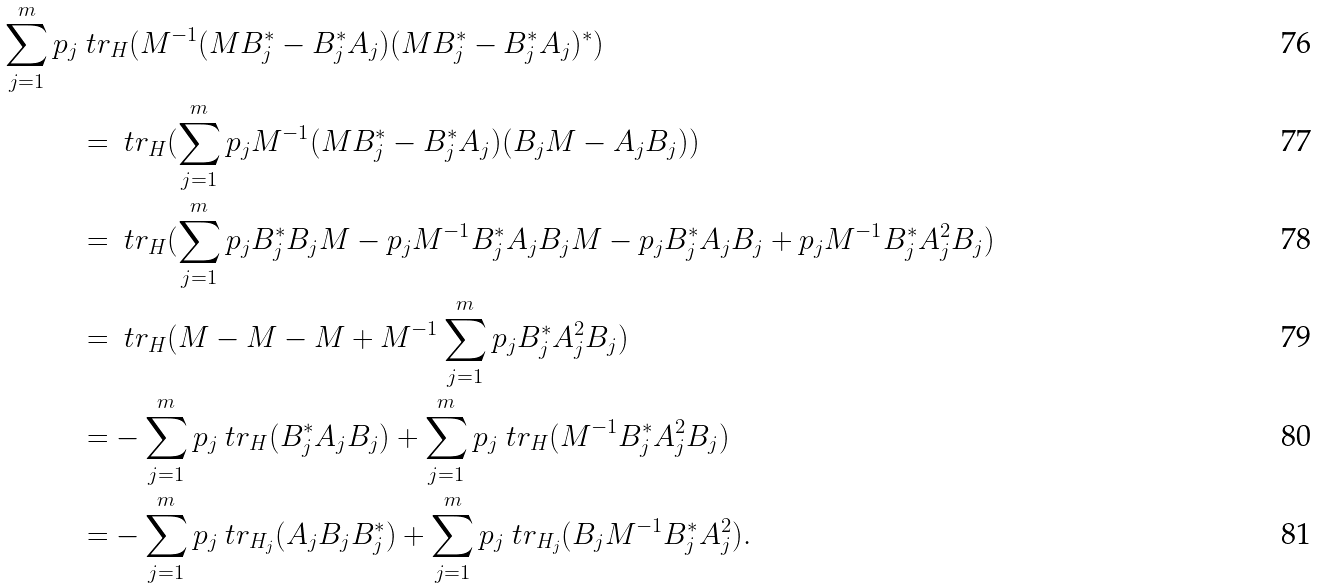<formula> <loc_0><loc_0><loc_500><loc_500>\sum _ { j = 1 } ^ { m } p _ { j } & \ t r _ { H } ( M ^ { - 1 } ( M B _ { j } ^ { * } - B _ { j } ^ { * } A _ { j } ) ( M B _ { j } ^ { * } - B _ { j } ^ { * } A _ { j } ) ^ { * } ) \\ & = \ t r _ { H } ( \sum _ { j = 1 } ^ { m } p _ { j } M ^ { - 1 } ( M B _ { j } ^ { * } - B _ { j } ^ { * } A _ { j } ) ( B _ { j } M - A _ { j } B _ { j } ) ) \\ & = \ t r _ { H } ( \sum _ { j = 1 } ^ { m } p _ { j } B _ { j } ^ { * } B _ { j } M - p _ { j } M ^ { - 1 } B _ { j } ^ { * } A _ { j } B _ { j } M - p _ { j } B _ { j } ^ { * } A _ { j } B _ { j } + p _ { j } M ^ { - 1 } B _ { j } ^ { * } A _ { j } ^ { 2 } B _ { j } ) \\ & = \ t r _ { H } ( M - M - M + M ^ { - 1 } \sum _ { j = 1 } ^ { m } p _ { j } B _ { j } ^ { * } A _ { j } ^ { 2 } B _ { j } ) \\ & = - \sum _ { j = 1 } ^ { m } p _ { j } \ t r _ { H } ( B _ { j } ^ { * } A _ { j } B _ { j } ) + \sum _ { j = 1 } ^ { m } p _ { j } \ t r _ { H } ( M ^ { - 1 } B _ { j } ^ { * } A _ { j } ^ { 2 } B _ { j } ) \\ & = - \sum _ { j = 1 } ^ { m } p _ { j } \ t r _ { H _ { j } } ( A _ { j } B _ { j } B _ { j } ^ { * } ) + \sum _ { j = 1 } ^ { m } p _ { j } \ t r _ { H _ { j } } ( B _ { j } M ^ { - 1 } B _ { j } ^ { * } A _ { j } ^ { 2 } ) .</formula> 